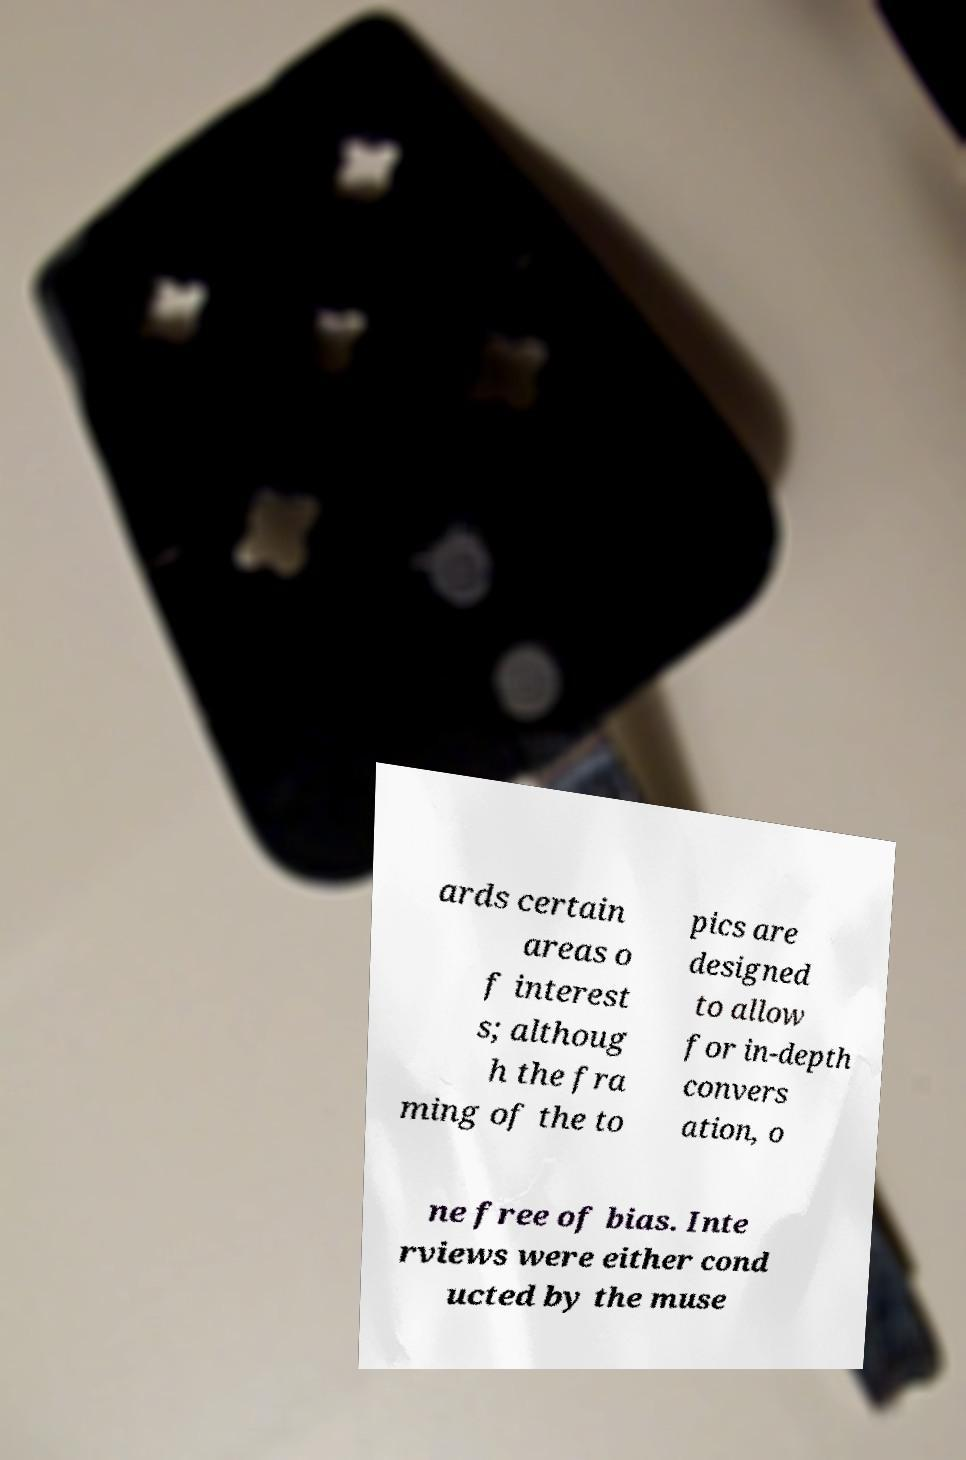There's text embedded in this image that I need extracted. Can you transcribe it verbatim? ards certain areas o f interest s; althoug h the fra ming of the to pics are designed to allow for in-depth convers ation, o ne free of bias. Inte rviews were either cond ucted by the muse 